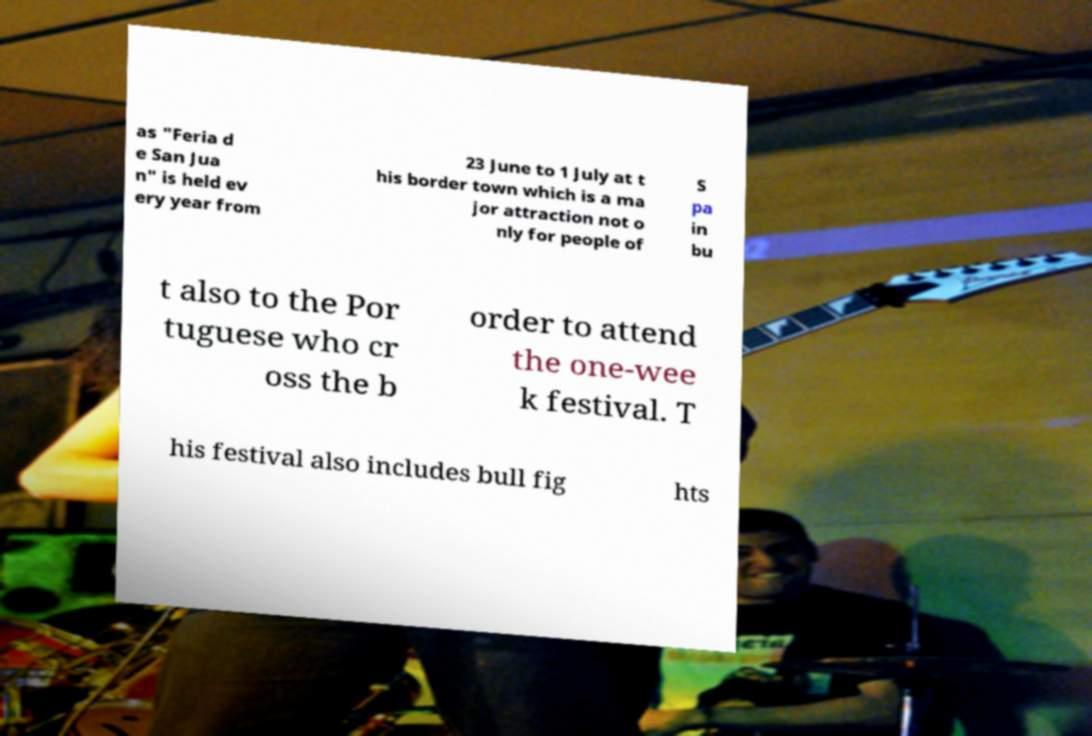For documentation purposes, I need the text within this image transcribed. Could you provide that? as "Feria d e San Jua n" is held ev ery year from 23 June to 1 July at t his border town which is a ma jor attraction not o nly for people of S pa in bu t also to the Por tuguese who cr oss the b order to attend the one-wee k festival. T his festival also includes bull fig hts 